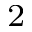Convert formula to latex. <formula><loc_0><loc_0><loc_500><loc_500>^ { 2 }</formula> 